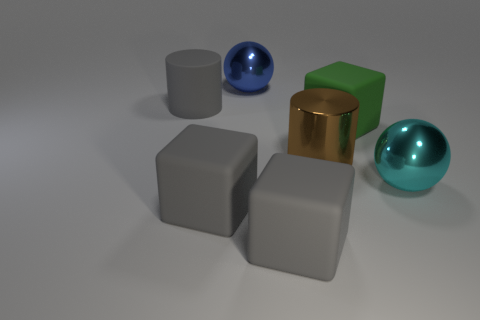Add 2 large blue blocks. How many objects exist? 9 Subtract all balls. How many objects are left? 5 Subtract 1 brown cylinders. How many objects are left? 6 Subtract all large blue rubber objects. Subtract all gray rubber cylinders. How many objects are left? 6 Add 3 large brown metal things. How many large brown metal things are left? 4 Add 2 red shiny cylinders. How many red shiny cylinders exist? 2 